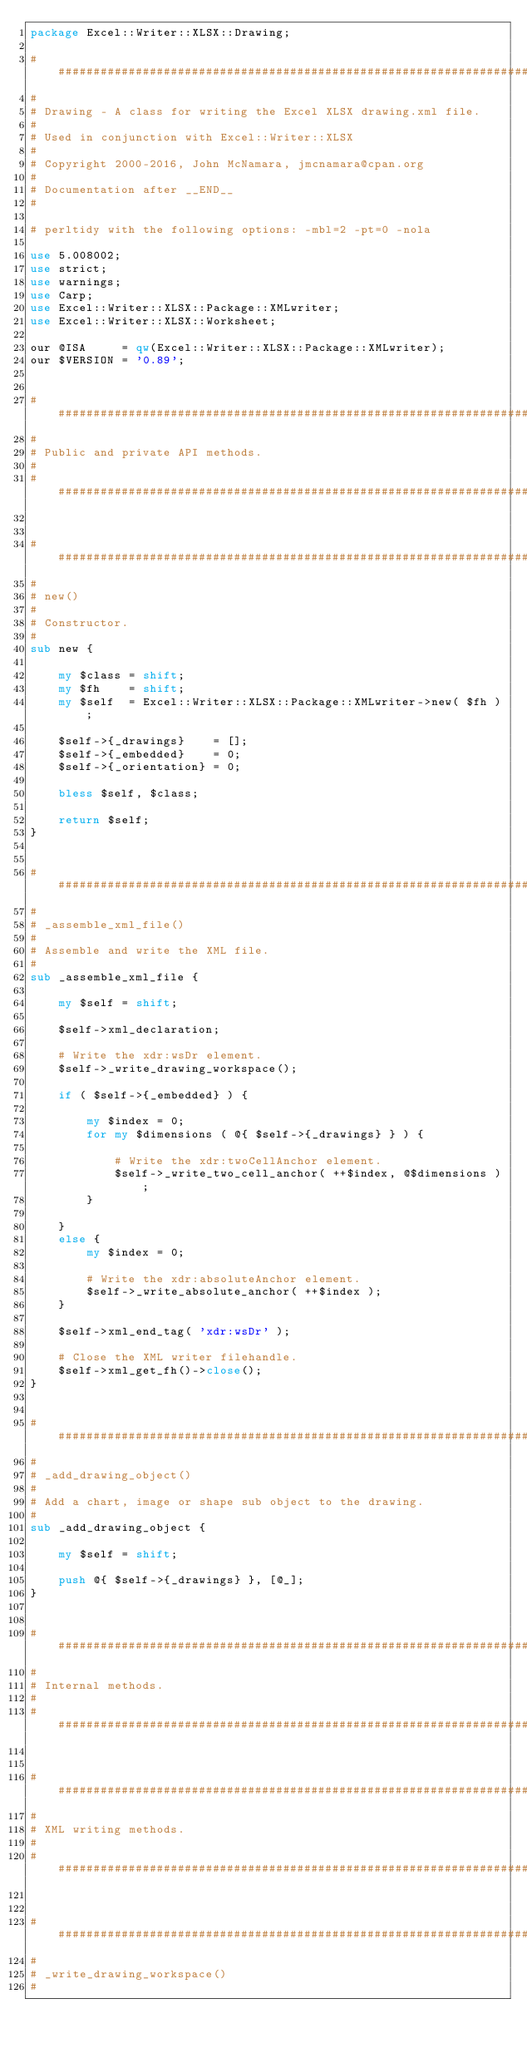Convert code to text. <code><loc_0><loc_0><loc_500><loc_500><_Perl_>package Excel::Writer::XLSX::Drawing;

###############################################################################
#
# Drawing - A class for writing the Excel XLSX drawing.xml file.
#
# Used in conjunction with Excel::Writer::XLSX
#
# Copyright 2000-2016, John McNamara, jmcnamara@cpan.org
#
# Documentation after __END__
#

# perltidy with the following options: -mbl=2 -pt=0 -nola

use 5.008002;
use strict;
use warnings;
use Carp;
use Excel::Writer::XLSX::Package::XMLwriter;
use Excel::Writer::XLSX::Worksheet;

our @ISA     = qw(Excel::Writer::XLSX::Package::XMLwriter);
our $VERSION = '0.89';


###############################################################################
#
# Public and private API methods.
#
###############################################################################


###############################################################################
#
# new()
#
# Constructor.
#
sub new {

    my $class = shift;
    my $fh    = shift;
    my $self  = Excel::Writer::XLSX::Package::XMLwriter->new( $fh );

    $self->{_drawings}    = [];
    $self->{_embedded}    = 0;
    $self->{_orientation} = 0;

    bless $self, $class;

    return $self;
}


###############################################################################
#
# _assemble_xml_file()
#
# Assemble and write the XML file.
#
sub _assemble_xml_file {

    my $self = shift;

    $self->xml_declaration;

    # Write the xdr:wsDr element.
    $self->_write_drawing_workspace();

    if ( $self->{_embedded} ) {

        my $index = 0;
        for my $dimensions ( @{ $self->{_drawings} } ) {

            # Write the xdr:twoCellAnchor element.
            $self->_write_two_cell_anchor( ++$index, @$dimensions );
        }

    }
    else {
        my $index = 0;

        # Write the xdr:absoluteAnchor element.
        $self->_write_absolute_anchor( ++$index );
    }

    $self->xml_end_tag( 'xdr:wsDr' );

    # Close the XML writer filehandle.
    $self->xml_get_fh()->close();
}


###############################################################################
#
# _add_drawing_object()
#
# Add a chart, image or shape sub object to the drawing.
#
sub _add_drawing_object {

    my $self = shift;

    push @{ $self->{_drawings} }, [@_];
}


###############################################################################
#
# Internal methods.
#
###############################################################################


###############################################################################
#
# XML writing methods.
#
###############################################################################


##############################################################################
#
# _write_drawing_workspace()
#</code> 